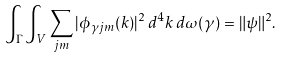Convert formula to latex. <formula><loc_0><loc_0><loc_500><loc_500>\int _ { \Gamma } \int _ { V } \sum _ { j m } | \phi _ { \gamma j m } ( k ) | ^ { 2 } \, d ^ { 4 } k \, d \omega ( \gamma ) = \| \psi \| ^ { 2 } .</formula> 